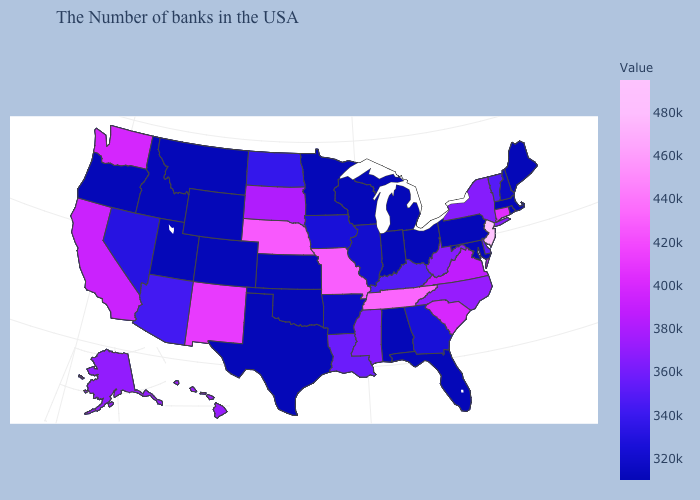Among the states that border Pennsylvania , does New Jersey have the highest value?
Concise answer only. Yes. Which states have the highest value in the USA?
Write a very short answer. New Jersey. Among the states that border New Hampshire , which have the highest value?
Give a very brief answer. Vermont. Does Tennessee have the highest value in the South?
Keep it brief. Yes. Among the states that border West Virginia , does Pennsylvania have the lowest value?
Concise answer only. Yes. Among the states that border Oklahoma , does Missouri have the highest value?
Keep it brief. Yes. Among the states that border Virginia , does Maryland have the lowest value?
Write a very short answer. Yes. 